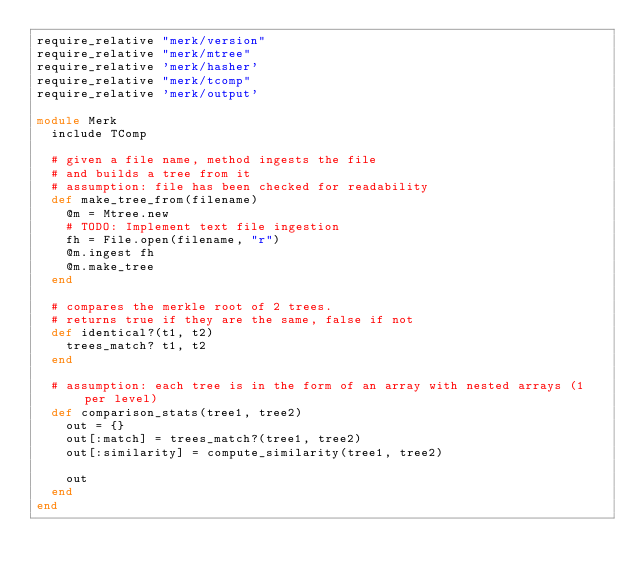Convert code to text. <code><loc_0><loc_0><loc_500><loc_500><_Ruby_>require_relative "merk/version"
require_relative "merk/mtree"
require_relative 'merk/hasher'
require_relative "merk/tcomp"
require_relative 'merk/output'

module Merk
  include TComp
  
  # given a file name, method ingests the file
  # and builds a tree from it
  # assumption: file has been checked for readability
  def make_tree_from(filename)
    @m = Mtree.new
    # TODO: Implement text file ingestion
    fh = File.open(filename, "r")
    @m.ingest fh
    @m.make_tree 
  end
  
  # compares the merkle root of 2 trees.
  # returns true if they are the same, false if not
  def identical?(t1, t2)
    trees_match? t1, t2
  end
  
  # assumption: each tree is in the form of an array with nested arrays (1 per level)
  def comparison_stats(tree1, tree2)
    out = {}
    out[:match] = trees_match?(tree1, tree2)
    out[:similarity] = compute_similarity(tree1, tree2)
     
    out
  end
end
</code> 